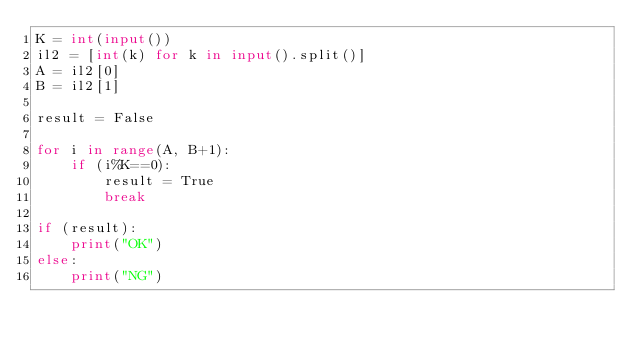<code> <loc_0><loc_0><loc_500><loc_500><_Python_>K = int(input())
il2 = [int(k) for k in input().split()]
A = il2[0]
B = il2[1]

result = False

for i in range(A, B+1):
    if (i%K==0):
        result = True
        break

if (result):
    print("OK")
else:
    print("NG")
</code> 